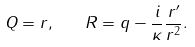Convert formula to latex. <formula><loc_0><loc_0><loc_500><loc_500>Q = r , \quad R = q - \frac { i } { \kappa } \frac { r ^ { \prime } } { r ^ { 2 } } .</formula> 